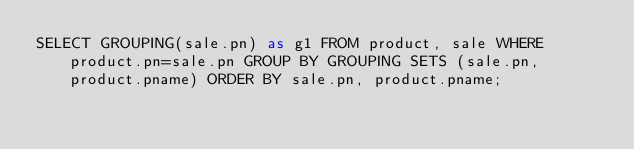Convert code to text. <code><loc_0><loc_0><loc_500><loc_500><_SQL_>SELECT GROUPING(sale.pn) as g1 FROM product, sale WHERE product.pn=sale.pn GROUP BY GROUPING SETS (sale.pn, product.pname) ORDER BY sale.pn, product.pname;
</code> 